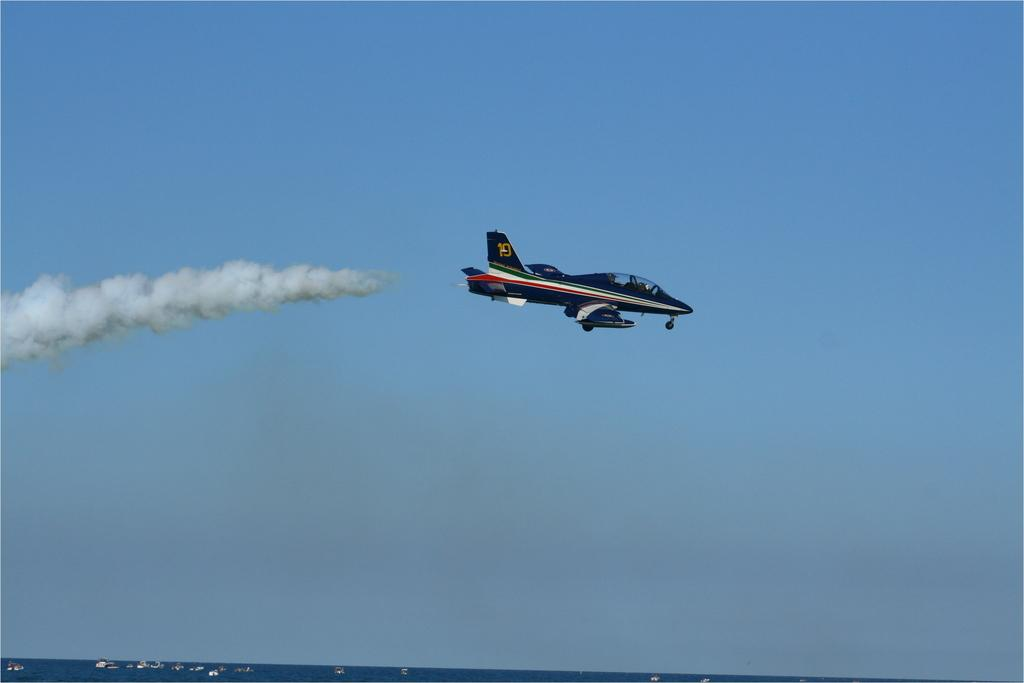<image>
Share a concise interpretation of the image provided. A jet plane has the number 10 on it's tail. 